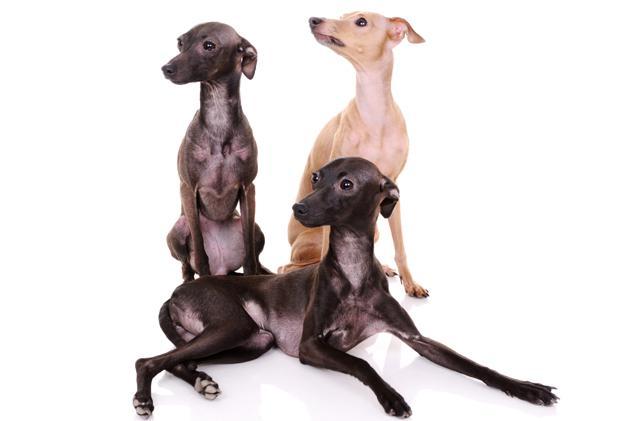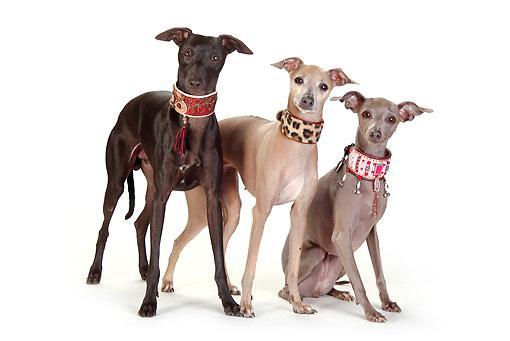The first image is the image on the left, the second image is the image on the right. For the images displayed, is the sentence "Each image contains exactly three hounds, including one image of dogs posed in a horizontal row." factually correct? Answer yes or no. Yes. The first image is the image on the left, the second image is the image on the right. Assess this claim about the two images: "There are six dogs in total.". Correct or not? Answer yes or no. Yes. 